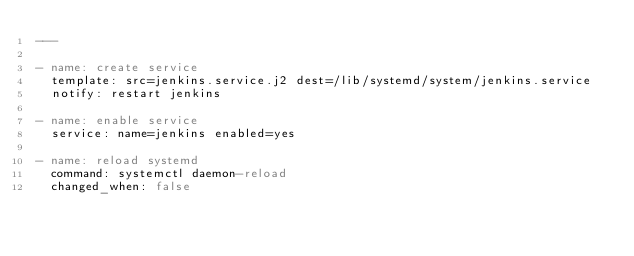<code> <loc_0><loc_0><loc_500><loc_500><_YAML_>---

- name: create service
  template: src=jenkins.service.j2 dest=/lib/systemd/system/jenkins.service
  notify: restart jenkins
  
- name: enable service
  service: name=jenkins enabled=yes
  
- name: reload systemd
  command: systemctl daemon-reload
  changed_when: false
</code> 